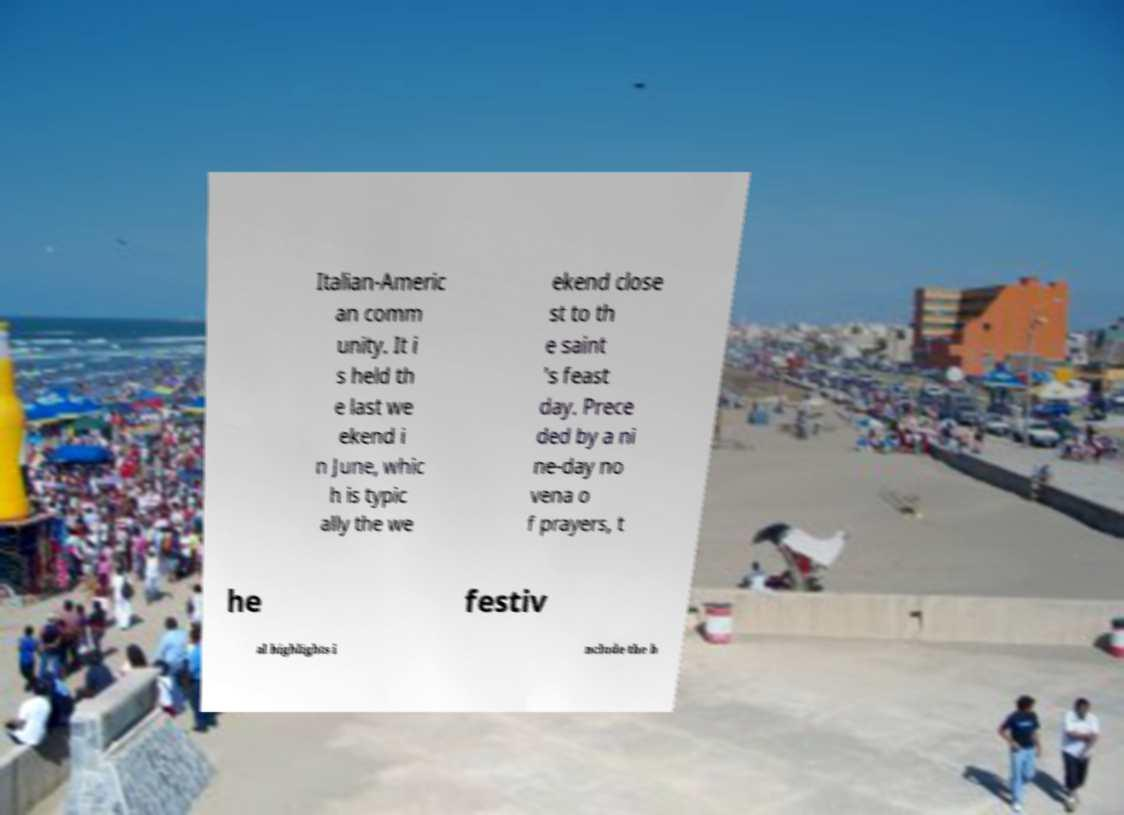Please read and relay the text visible in this image. What does it say? Italian-Americ an comm unity. It i s held th e last we ekend i n June, whic h is typic ally the we ekend close st to th e saint 's feast day. Prece ded by a ni ne-day no vena o f prayers, t he festiv al highlights i nclude the b 